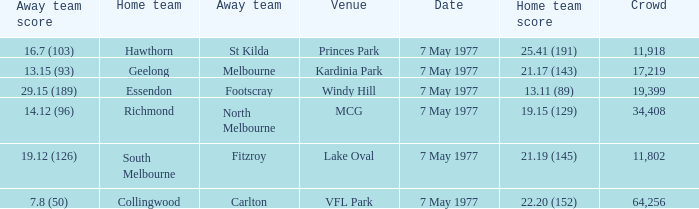Name the venue with a home team of geelong Kardinia Park. 